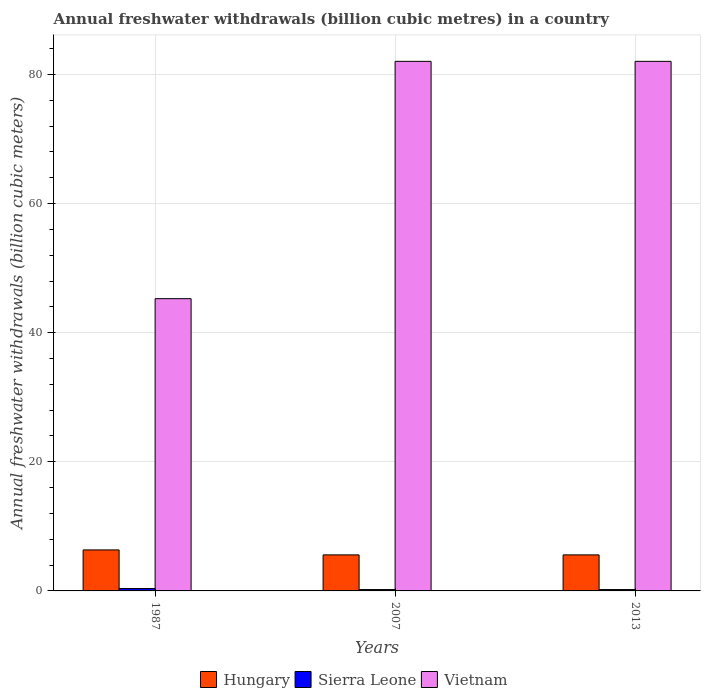How many different coloured bars are there?
Offer a terse response. 3. How many groups of bars are there?
Offer a terse response. 3. Are the number of bars per tick equal to the number of legend labels?
Provide a succinct answer. Yes. Are the number of bars on each tick of the X-axis equal?
Offer a terse response. Yes. How many bars are there on the 1st tick from the left?
Offer a very short reply. 3. How many bars are there on the 3rd tick from the right?
Ensure brevity in your answer.  3. What is the annual freshwater withdrawals in Vietnam in 2013?
Ensure brevity in your answer.  82.03. Across all years, what is the maximum annual freshwater withdrawals in Sierra Leone?
Keep it short and to the point. 0.37. Across all years, what is the minimum annual freshwater withdrawals in Hungary?
Give a very brief answer. 5.58. In which year was the annual freshwater withdrawals in Vietnam minimum?
Offer a terse response. 1987. What is the total annual freshwater withdrawals in Vietnam in the graph?
Keep it short and to the point. 209.33. What is the difference between the annual freshwater withdrawals in Vietnam in 1987 and that in 2013?
Provide a short and direct response. -36.76. What is the difference between the annual freshwater withdrawals in Hungary in 2007 and the annual freshwater withdrawals in Vietnam in 2013?
Provide a succinct answer. -76.45. What is the average annual freshwater withdrawals in Sierra Leone per year?
Keep it short and to the point. 0.26. In the year 1987, what is the difference between the annual freshwater withdrawals in Hungary and annual freshwater withdrawals in Vietnam?
Keep it short and to the point. -38.92. What is the ratio of the annual freshwater withdrawals in Vietnam in 1987 to that in 2013?
Give a very brief answer. 0.55. Is the annual freshwater withdrawals in Hungary in 1987 less than that in 2013?
Offer a very short reply. No. What is the difference between the highest and the second highest annual freshwater withdrawals in Sierra Leone?
Your answer should be very brief. 0.16. What is the difference between the highest and the lowest annual freshwater withdrawals in Hungary?
Keep it short and to the point. 0.77. In how many years, is the annual freshwater withdrawals in Sierra Leone greater than the average annual freshwater withdrawals in Sierra Leone taken over all years?
Offer a very short reply. 1. Is the sum of the annual freshwater withdrawals in Sierra Leone in 1987 and 2007 greater than the maximum annual freshwater withdrawals in Vietnam across all years?
Provide a short and direct response. No. What does the 3rd bar from the left in 1987 represents?
Provide a short and direct response. Vietnam. What does the 2nd bar from the right in 1987 represents?
Offer a terse response. Sierra Leone. How many bars are there?
Your response must be concise. 9. Are all the bars in the graph horizontal?
Offer a terse response. No. How many years are there in the graph?
Give a very brief answer. 3. Does the graph contain any zero values?
Your answer should be compact. No. How many legend labels are there?
Keep it short and to the point. 3. How are the legend labels stacked?
Provide a succinct answer. Horizontal. What is the title of the graph?
Your answer should be very brief. Annual freshwater withdrawals (billion cubic metres) in a country. Does "Guyana" appear as one of the legend labels in the graph?
Keep it short and to the point. No. What is the label or title of the X-axis?
Your response must be concise. Years. What is the label or title of the Y-axis?
Ensure brevity in your answer.  Annual freshwater withdrawals (billion cubic meters). What is the Annual freshwater withdrawals (billion cubic meters) of Hungary in 1987?
Make the answer very short. 6.35. What is the Annual freshwater withdrawals (billion cubic meters) in Sierra Leone in 1987?
Offer a very short reply. 0.37. What is the Annual freshwater withdrawals (billion cubic meters) in Vietnam in 1987?
Keep it short and to the point. 45.27. What is the Annual freshwater withdrawals (billion cubic meters) in Hungary in 2007?
Make the answer very short. 5.58. What is the Annual freshwater withdrawals (billion cubic meters) in Sierra Leone in 2007?
Provide a succinct answer. 0.21. What is the Annual freshwater withdrawals (billion cubic meters) of Vietnam in 2007?
Keep it short and to the point. 82.03. What is the Annual freshwater withdrawals (billion cubic meters) in Hungary in 2013?
Give a very brief answer. 5.58. What is the Annual freshwater withdrawals (billion cubic meters) in Sierra Leone in 2013?
Keep it short and to the point. 0.21. What is the Annual freshwater withdrawals (billion cubic meters) of Vietnam in 2013?
Ensure brevity in your answer.  82.03. Across all years, what is the maximum Annual freshwater withdrawals (billion cubic meters) in Hungary?
Ensure brevity in your answer.  6.35. Across all years, what is the maximum Annual freshwater withdrawals (billion cubic meters) in Sierra Leone?
Your response must be concise. 0.37. Across all years, what is the maximum Annual freshwater withdrawals (billion cubic meters) of Vietnam?
Make the answer very short. 82.03. Across all years, what is the minimum Annual freshwater withdrawals (billion cubic meters) in Hungary?
Ensure brevity in your answer.  5.58. Across all years, what is the minimum Annual freshwater withdrawals (billion cubic meters) in Sierra Leone?
Your answer should be very brief. 0.21. Across all years, what is the minimum Annual freshwater withdrawals (billion cubic meters) in Vietnam?
Offer a very short reply. 45.27. What is the total Annual freshwater withdrawals (billion cubic meters) in Hungary in the graph?
Provide a succinct answer. 17.52. What is the total Annual freshwater withdrawals (billion cubic meters) of Sierra Leone in the graph?
Your answer should be very brief. 0.79. What is the total Annual freshwater withdrawals (billion cubic meters) of Vietnam in the graph?
Provide a short and direct response. 209.33. What is the difference between the Annual freshwater withdrawals (billion cubic meters) in Hungary in 1987 and that in 2007?
Ensure brevity in your answer.  0.77. What is the difference between the Annual freshwater withdrawals (billion cubic meters) in Sierra Leone in 1987 and that in 2007?
Provide a succinct answer. 0.16. What is the difference between the Annual freshwater withdrawals (billion cubic meters) in Vietnam in 1987 and that in 2007?
Provide a succinct answer. -36.76. What is the difference between the Annual freshwater withdrawals (billion cubic meters) of Hungary in 1987 and that in 2013?
Your answer should be very brief. 0.77. What is the difference between the Annual freshwater withdrawals (billion cubic meters) in Sierra Leone in 1987 and that in 2013?
Offer a very short reply. 0.16. What is the difference between the Annual freshwater withdrawals (billion cubic meters) of Vietnam in 1987 and that in 2013?
Your answer should be very brief. -36.76. What is the difference between the Annual freshwater withdrawals (billion cubic meters) of Hungary in 2007 and that in 2013?
Make the answer very short. 0. What is the difference between the Annual freshwater withdrawals (billion cubic meters) of Sierra Leone in 2007 and that in 2013?
Offer a terse response. 0. What is the difference between the Annual freshwater withdrawals (billion cubic meters) of Vietnam in 2007 and that in 2013?
Provide a succinct answer. 0. What is the difference between the Annual freshwater withdrawals (billion cubic meters) of Hungary in 1987 and the Annual freshwater withdrawals (billion cubic meters) of Sierra Leone in 2007?
Offer a terse response. 6.14. What is the difference between the Annual freshwater withdrawals (billion cubic meters) of Hungary in 1987 and the Annual freshwater withdrawals (billion cubic meters) of Vietnam in 2007?
Your answer should be very brief. -75.68. What is the difference between the Annual freshwater withdrawals (billion cubic meters) in Sierra Leone in 1987 and the Annual freshwater withdrawals (billion cubic meters) in Vietnam in 2007?
Offer a terse response. -81.66. What is the difference between the Annual freshwater withdrawals (billion cubic meters) in Hungary in 1987 and the Annual freshwater withdrawals (billion cubic meters) in Sierra Leone in 2013?
Provide a succinct answer. 6.14. What is the difference between the Annual freshwater withdrawals (billion cubic meters) in Hungary in 1987 and the Annual freshwater withdrawals (billion cubic meters) in Vietnam in 2013?
Ensure brevity in your answer.  -75.68. What is the difference between the Annual freshwater withdrawals (billion cubic meters) of Sierra Leone in 1987 and the Annual freshwater withdrawals (billion cubic meters) of Vietnam in 2013?
Your response must be concise. -81.66. What is the difference between the Annual freshwater withdrawals (billion cubic meters) in Hungary in 2007 and the Annual freshwater withdrawals (billion cubic meters) in Sierra Leone in 2013?
Offer a very short reply. 5.37. What is the difference between the Annual freshwater withdrawals (billion cubic meters) in Hungary in 2007 and the Annual freshwater withdrawals (billion cubic meters) in Vietnam in 2013?
Your response must be concise. -76.45. What is the difference between the Annual freshwater withdrawals (billion cubic meters) in Sierra Leone in 2007 and the Annual freshwater withdrawals (billion cubic meters) in Vietnam in 2013?
Offer a very short reply. -81.82. What is the average Annual freshwater withdrawals (billion cubic meters) in Hungary per year?
Make the answer very short. 5.84. What is the average Annual freshwater withdrawals (billion cubic meters) of Sierra Leone per year?
Ensure brevity in your answer.  0.26. What is the average Annual freshwater withdrawals (billion cubic meters) of Vietnam per year?
Provide a short and direct response. 69.78. In the year 1987, what is the difference between the Annual freshwater withdrawals (billion cubic meters) of Hungary and Annual freshwater withdrawals (billion cubic meters) of Sierra Leone?
Your response must be concise. 5.98. In the year 1987, what is the difference between the Annual freshwater withdrawals (billion cubic meters) in Hungary and Annual freshwater withdrawals (billion cubic meters) in Vietnam?
Your answer should be very brief. -38.92. In the year 1987, what is the difference between the Annual freshwater withdrawals (billion cubic meters) of Sierra Leone and Annual freshwater withdrawals (billion cubic meters) of Vietnam?
Give a very brief answer. -44.9. In the year 2007, what is the difference between the Annual freshwater withdrawals (billion cubic meters) of Hungary and Annual freshwater withdrawals (billion cubic meters) of Sierra Leone?
Give a very brief answer. 5.37. In the year 2007, what is the difference between the Annual freshwater withdrawals (billion cubic meters) of Hungary and Annual freshwater withdrawals (billion cubic meters) of Vietnam?
Provide a succinct answer. -76.45. In the year 2007, what is the difference between the Annual freshwater withdrawals (billion cubic meters) in Sierra Leone and Annual freshwater withdrawals (billion cubic meters) in Vietnam?
Provide a succinct answer. -81.82. In the year 2013, what is the difference between the Annual freshwater withdrawals (billion cubic meters) of Hungary and Annual freshwater withdrawals (billion cubic meters) of Sierra Leone?
Give a very brief answer. 5.37. In the year 2013, what is the difference between the Annual freshwater withdrawals (billion cubic meters) in Hungary and Annual freshwater withdrawals (billion cubic meters) in Vietnam?
Keep it short and to the point. -76.45. In the year 2013, what is the difference between the Annual freshwater withdrawals (billion cubic meters) in Sierra Leone and Annual freshwater withdrawals (billion cubic meters) in Vietnam?
Offer a very short reply. -81.82. What is the ratio of the Annual freshwater withdrawals (billion cubic meters) of Hungary in 1987 to that in 2007?
Provide a succinct answer. 1.14. What is the ratio of the Annual freshwater withdrawals (billion cubic meters) in Sierra Leone in 1987 to that in 2007?
Make the answer very short. 1.74. What is the ratio of the Annual freshwater withdrawals (billion cubic meters) in Vietnam in 1987 to that in 2007?
Provide a short and direct response. 0.55. What is the ratio of the Annual freshwater withdrawals (billion cubic meters) in Hungary in 1987 to that in 2013?
Provide a short and direct response. 1.14. What is the ratio of the Annual freshwater withdrawals (billion cubic meters) in Sierra Leone in 1987 to that in 2013?
Make the answer very short. 1.74. What is the ratio of the Annual freshwater withdrawals (billion cubic meters) in Vietnam in 1987 to that in 2013?
Keep it short and to the point. 0.55. What is the ratio of the Annual freshwater withdrawals (billion cubic meters) of Hungary in 2007 to that in 2013?
Keep it short and to the point. 1. What is the ratio of the Annual freshwater withdrawals (billion cubic meters) of Sierra Leone in 2007 to that in 2013?
Your answer should be very brief. 1. What is the difference between the highest and the second highest Annual freshwater withdrawals (billion cubic meters) of Hungary?
Your response must be concise. 0.77. What is the difference between the highest and the second highest Annual freshwater withdrawals (billion cubic meters) of Sierra Leone?
Your answer should be very brief. 0.16. What is the difference between the highest and the second highest Annual freshwater withdrawals (billion cubic meters) of Vietnam?
Give a very brief answer. 0. What is the difference between the highest and the lowest Annual freshwater withdrawals (billion cubic meters) of Hungary?
Keep it short and to the point. 0.77. What is the difference between the highest and the lowest Annual freshwater withdrawals (billion cubic meters) of Sierra Leone?
Your answer should be very brief. 0.16. What is the difference between the highest and the lowest Annual freshwater withdrawals (billion cubic meters) in Vietnam?
Provide a short and direct response. 36.76. 